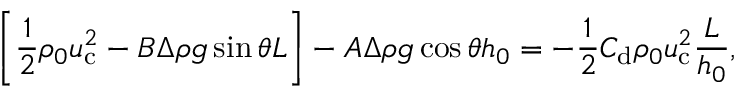Convert formula to latex. <formula><loc_0><loc_0><loc_500><loc_500>\left [ \frac { 1 } { 2 } \rho _ { 0 } u _ { c } ^ { 2 } - B \Delta \rho g \sin \theta L \right ] - A \Delta \rho g \cos \theta h _ { 0 } = - \frac { 1 } { 2 } C _ { d } \rho _ { 0 } u _ { c } ^ { 2 } \frac { L } { h _ { 0 } } ,</formula> 